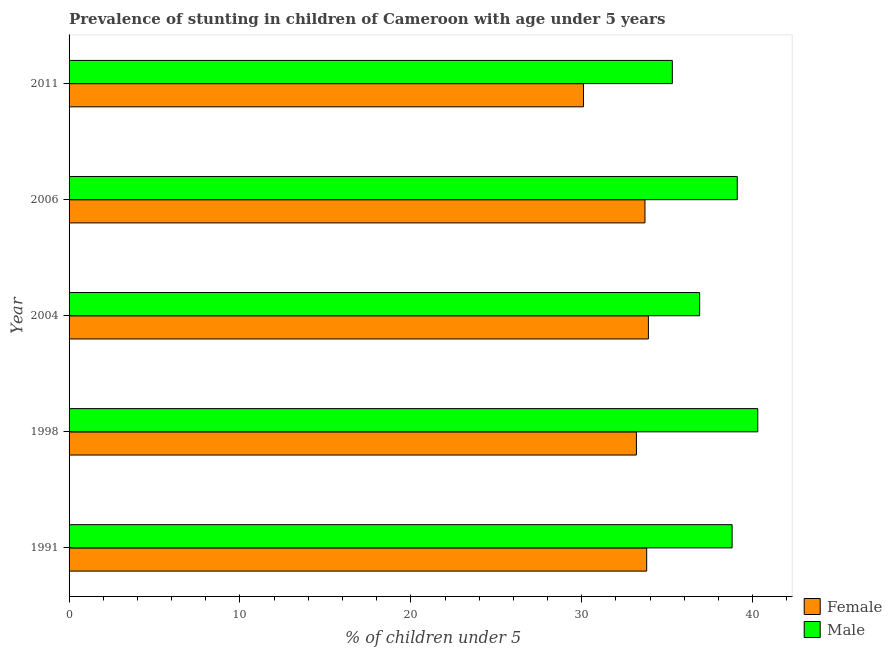How many different coloured bars are there?
Your response must be concise. 2. Are the number of bars per tick equal to the number of legend labels?
Ensure brevity in your answer.  Yes. What is the label of the 3rd group of bars from the top?
Your answer should be very brief. 2004. What is the percentage of stunted male children in 2004?
Your answer should be very brief. 36.9. Across all years, what is the maximum percentage of stunted male children?
Provide a succinct answer. 40.3. Across all years, what is the minimum percentage of stunted female children?
Keep it short and to the point. 30.1. In which year was the percentage of stunted male children minimum?
Provide a short and direct response. 2011. What is the total percentage of stunted female children in the graph?
Offer a very short reply. 164.7. What is the difference between the percentage of stunted male children in 1998 and the percentage of stunted female children in 1991?
Keep it short and to the point. 6.5. What is the average percentage of stunted female children per year?
Your response must be concise. 32.94. Is the percentage of stunted female children in 1991 less than that in 1998?
Make the answer very short. No. What is the difference between the highest and the second highest percentage of stunted male children?
Your answer should be very brief. 1.2. In how many years, is the percentage of stunted female children greater than the average percentage of stunted female children taken over all years?
Offer a terse response. 4. How many years are there in the graph?
Your answer should be very brief. 5. What is the difference between two consecutive major ticks on the X-axis?
Your answer should be compact. 10. How are the legend labels stacked?
Your answer should be compact. Vertical. What is the title of the graph?
Your answer should be very brief. Prevalence of stunting in children of Cameroon with age under 5 years. What is the label or title of the X-axis?
Give a very brief answer.  % of children under 5. What is the label or title of the Y-axis?
Give a very brief answer. Year. What is the  % of children under 5 of Female in 1991?
Keep it short and to the point. 33.8. What is the  % of children under 5 in Male in 1991?
Provide a succinct answer. 38.8. What is the  % of children under 5 of Female in 1998?
Provide a succinct answer. 33.2. What is the  % of children under 5 of Male in 1998?
Provide a succinct answer. 40.3. What is the  % of children under 5 of Female in 2004?
Give a very brief answer. 33.9. What is the  % of children under 5 in Male in 2004?
Your answer should be compact. 36.9. What is the  % of children under 5 of Female in 2006?
Offer a terse response. 33.7. What is the  % of children under 5 in Male in 2006?
Provide a succinct answer. 39.1. What is the  % of children under 5 of Female in 2011?
Offer a very short reply. 30.1. What is the  % of children under 5 of Male in 2011?
Your answer should be very brief. 35.3. Across all years, what is the maximum  % of children under 5 of Female?
Your answer should be compact. 33.9. Across all years, what is the maximum  % of children under 5 in Male?
Make the answer very short. 40.3. Across all years, what is the minimum  % of children under 5 of Female?
Provide a short and direct response. 30.1. Across all years, what is the minimum  % of children under 5 in Male?
Your response must be concise. 35.3. What is the total  % of children under 5 of Female in the graph?
Ensure brevity in your answer.  164.7. What is the total  % of children under 5 in Male in the graph?
Keep it short and to the point. 190.4. What is the difference between the  % of children under 5 of Female in 1991 and that in 1998?
Make the answer very short. 0.6. What is the difference between the  % of children under 5 of Male in 1991 and that in 1998?
Offer a terse response. -1.5. What is the difference between the  % of children under 5 in Female in 1991 and that in 2004?
Your answer should be very brief. -0.1. What is the difference between the  % of children under 5 in Male in 1991 and that in 2004?
Offer a very short reply. 1.9. What is the difference between the  % of children under 5 of Male in 1991 and that in 2011?
Keep it short and to the point. 3.5. What is the difference between the  % of children under 5 of Female in 1998 and that in 2004?
Make the answer very short. -0.7. What is the difference between the  % of children under 5 of Male in 1998 and that in 2004?
Your response must be concise. 3.4. What is the difference between the  % of children under 5 of Male in 1998 and that in 2006?
Your response must be concise. 1.2. What is the difference between the  % of children under 5 of Female in 1998 and that in 2011?
Ensure brevity in your answer.  3.1. What is the difference between the  % of children under 5 in Male in 1998 and that in 2011?
Ensure brevity in your answer.  5. What is the difference between the  % of children under 5 in Female in 2004 and that in 2006?
Your answer should be very brief. 0.2. What is the difference between the  % of children under 5 in Male in 2004 and that in 2006?
Keep it short and to the point. -2.2. What is the difference between the  % of children under 5 of Female in 2006 and that in 2011?
Make the answer very short. 3.6. What is the difference between the  % of children under 5 of Male in 2006 and that in 2011?
Offer a very short reply. 3.8. What is the difference between the  % of children under 5 of Female in 1991 and the  % of children under 5 of Male in 2006?
Provide a short and direct response. -5.3. What is the difference between the  % of children under 5 in Female in 1998 and the  % of children under 5 in Male in 2004?
Provide a short and direct response. -3.7. What is the difference between the  % of children under 5 of Female in 2004 and the  % of children under 5 of Male in 2011?
Keep it short and to the point. -1.4. What is the difference between the  % of children under 5 of Female in 2006 and the  % of children under 5 of Male in 2011?
Provide a succinct answer. -1.6. What is the average  % of children under 5 of Female per year?
Offer a very short reply. 32.94. What is the average  % of children under 5 in Male per year?
Your answer should be very brief. 38.08. In the year 1998, what is the difference between the  % of children under 5 of Female and  % of children under 5 of Male?
Your answer should be compact. -7.1. In the year 2004, what is the difference between the  % of children under 5 in Female and  % of children under 5 in Male?
Give a very brief answer. -3. In the year 2011, what is the difference between the  % of children under 5 in Female and  % of children under 5 in Male?
Give a very brief answer. -5.2. What is the ratio of the  % of children under 5 of Female in 1991 to that in 1998?
Your response must be concise. 1.02. What is the ratio of the  % of children under 5 of Male in 1991 to that in 1998?
Provide a succinct answer. 0.96. What is the ratio of the  % of children under 5 of Male in 1991 to that in 2004?
Make the answer very short. 1.05. What is the ratio of the  % of children under 5 of Female in 1991 to that in 2006?
Ensure brevity in your answer.  1. What is the ratio of the  % of children under 5 of Female in 1991 to that in 2011?
Keep it short and to the point. 1.12. What is the ratio of the  % of children under 5 in Male in 1991 to that in 2011?
Keep it short and to the point. 1.1. What is the ratio of the  % of children under 5 in Female in 1998 to that in 2004?
Ensure brevity in your answer.  0.98. What is the ratio of the  % of children under 5 in Male in 1998 to that in 2004?
Offer a terse response. 1.09. What is the ratio of the  % of children under 5 of Female in 1998 to that in 2006?
Your answer should be very brief. 0.99. What is the ratio of the  % of children under 5 in Male in 1998 to that in 2006?
Your answer should be compact. 1.03. What is the ratio of the  % of children under 5 in Female in 1998 to that in 2011?
Provide a short and direct response. 1.1. What is the ratio of the  % of children under 5 of Male in 1998 to that in 2011?
Ensure brevity in your answer.  1.14. What is the ratio of the  % of children under 5 of Female in 2004 to that in 2006?
Offer a terse response. 1.01. What is the ratio of the  % of children under 5 in Male in 2004 to that in 2006?
Ensure brevity in your answer.  0.94. What is the ratio of the  % of children under 5 of Female in 2004 to that in 2011?
Provide a short and direct response. 1.13. What is the ratio of the  % of children under 5 of Male in 2004 to that in 2011?
Your response must be concise. 1.05. What is the ratio of the  % of children under 5 of Female in 2006 to that in 2011?
Provide a succinct answer. 1.12. What is the ratio of the  % of children under 5 of Male in 2006 to that in 2011?
Keep it short and to the point. 1.11. What is the difference between the highest and the second highest  % of children under 5 of Female?
Offer a very short reply. 0.1. What is the difference between the highest and the second highest  % of children under 5 in Male?
Your answer should be compact. 1.2. What is the difference between the highest and the lowest  % of children under 5 in Female?
Provide a short and direct response. 3.8. What is the difference between the highest and the lowest  % of children under 5 in Male?
Your response must be concise. 5. 